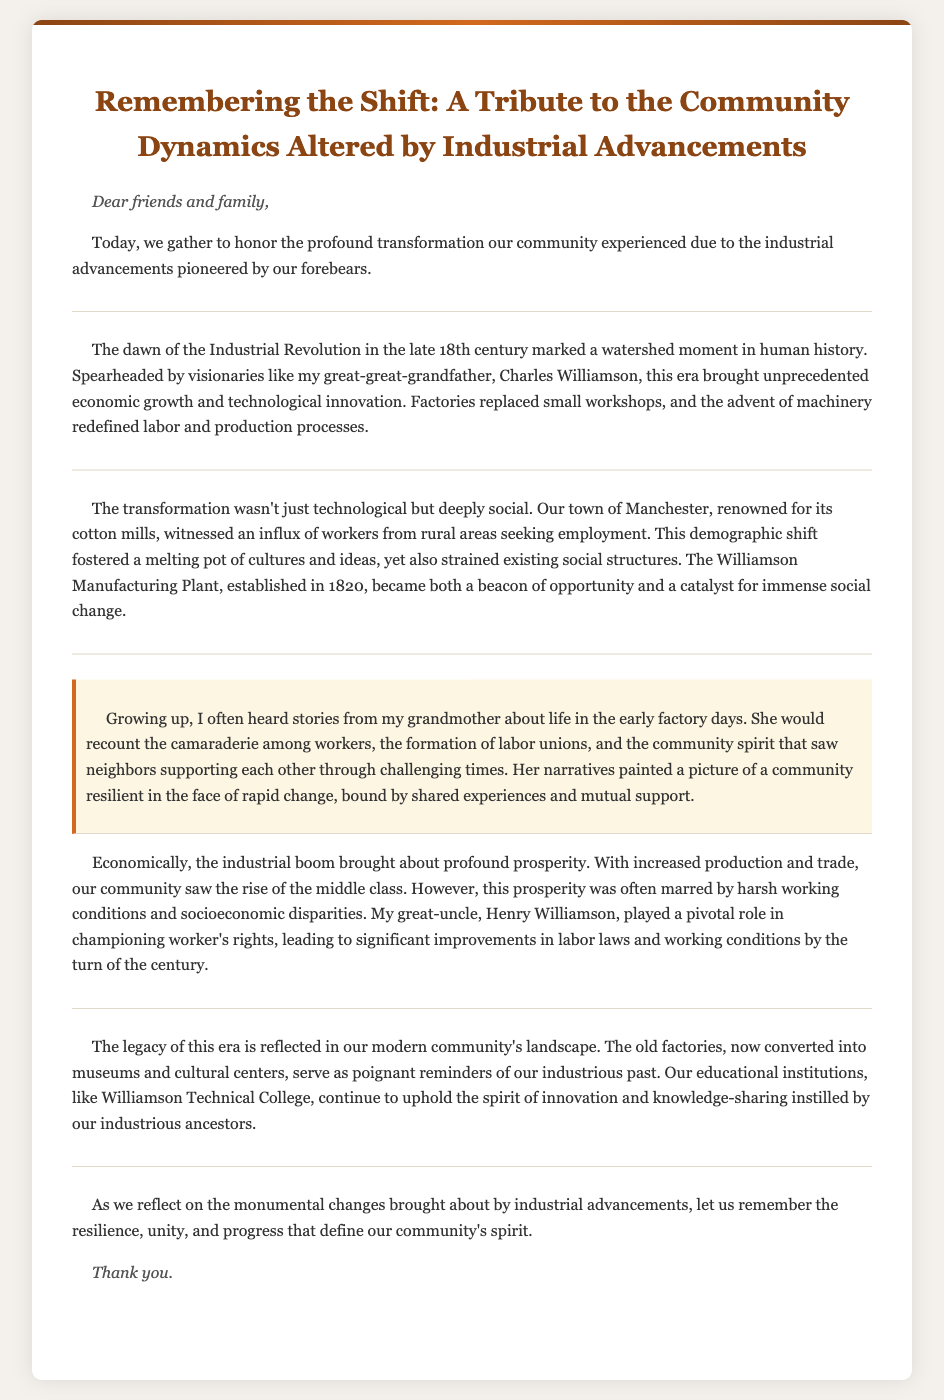What year was the Williamson Manufacturing Plant established? The document states that the Williamson Manufacturing Plant was established in 1820.
Answer: 1820 Who is mentioned as a pioneering figure of the Industrial Revolution in the document? The eulogy mentions Charles Williamson as a visionary who spearheaded the Industrial Revolution.
Answer: Charles Williamson What significant impact did the industrial advancements have on the workforce? The document notes an influx of workers from rural areas seeking employment due to industrial advancements.
Answer: Influx of workers What role did Henry Williamson play in the community? Henry Williamson is described as having a pivotal role in championing worker's rights leading to improved labor laws.
Answer: Championing worker's rights What type of institution continues the spirit of innovation according to the document? The document references Williamson Technical College as an educational institution upholding the spirit of innovation.
Answer: Williamson Technical College What social aspect was highlighted in the grandmother's stories? The stories from the grandmother highlight the camaraderie among workers and community spirit during challenging times.
Answer: Camaraderie among workers What is suggested as a legacy of the industrial era in the community? The document mentions that old factories have been converted into museums and cultural centers as a legacy of the industrial era.
Answer: Museums and cultural centers What phrase encapsulates the spirit of the community as reflected upon in the eulogy? The eulogy concludes with the phrase "resilience, unity, and progress" which encapsulates the community's spirit.
Answer: Resilience, unity, and progress 